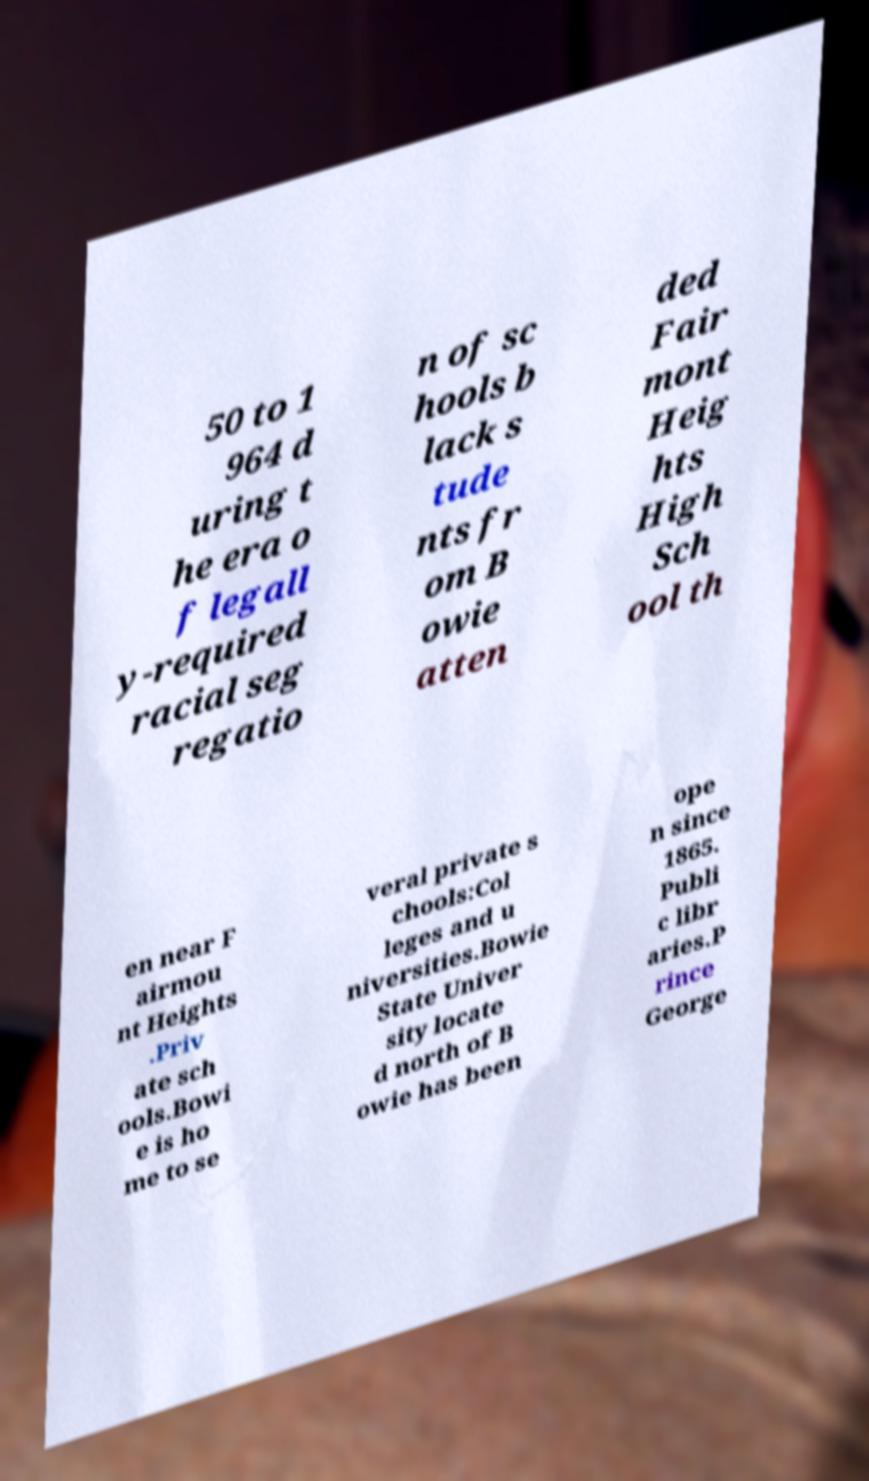Please identify and transcribe the text found in this image. 50 to 1 964 d uring t he era o f legall y-required racial seg regatio n of sc hools b lack s tude nts fr om B owie atten ded Fair mont Heig hts High Sch ool th en near F airmou nt Heights .Priv ate sch ools.Bowi e is ho me to se veral private s chools:Col leges and u niversities.Bowie State Univer sity locate d north of B owie has been ope n since 1865. Publi c libr aries.P rince George 